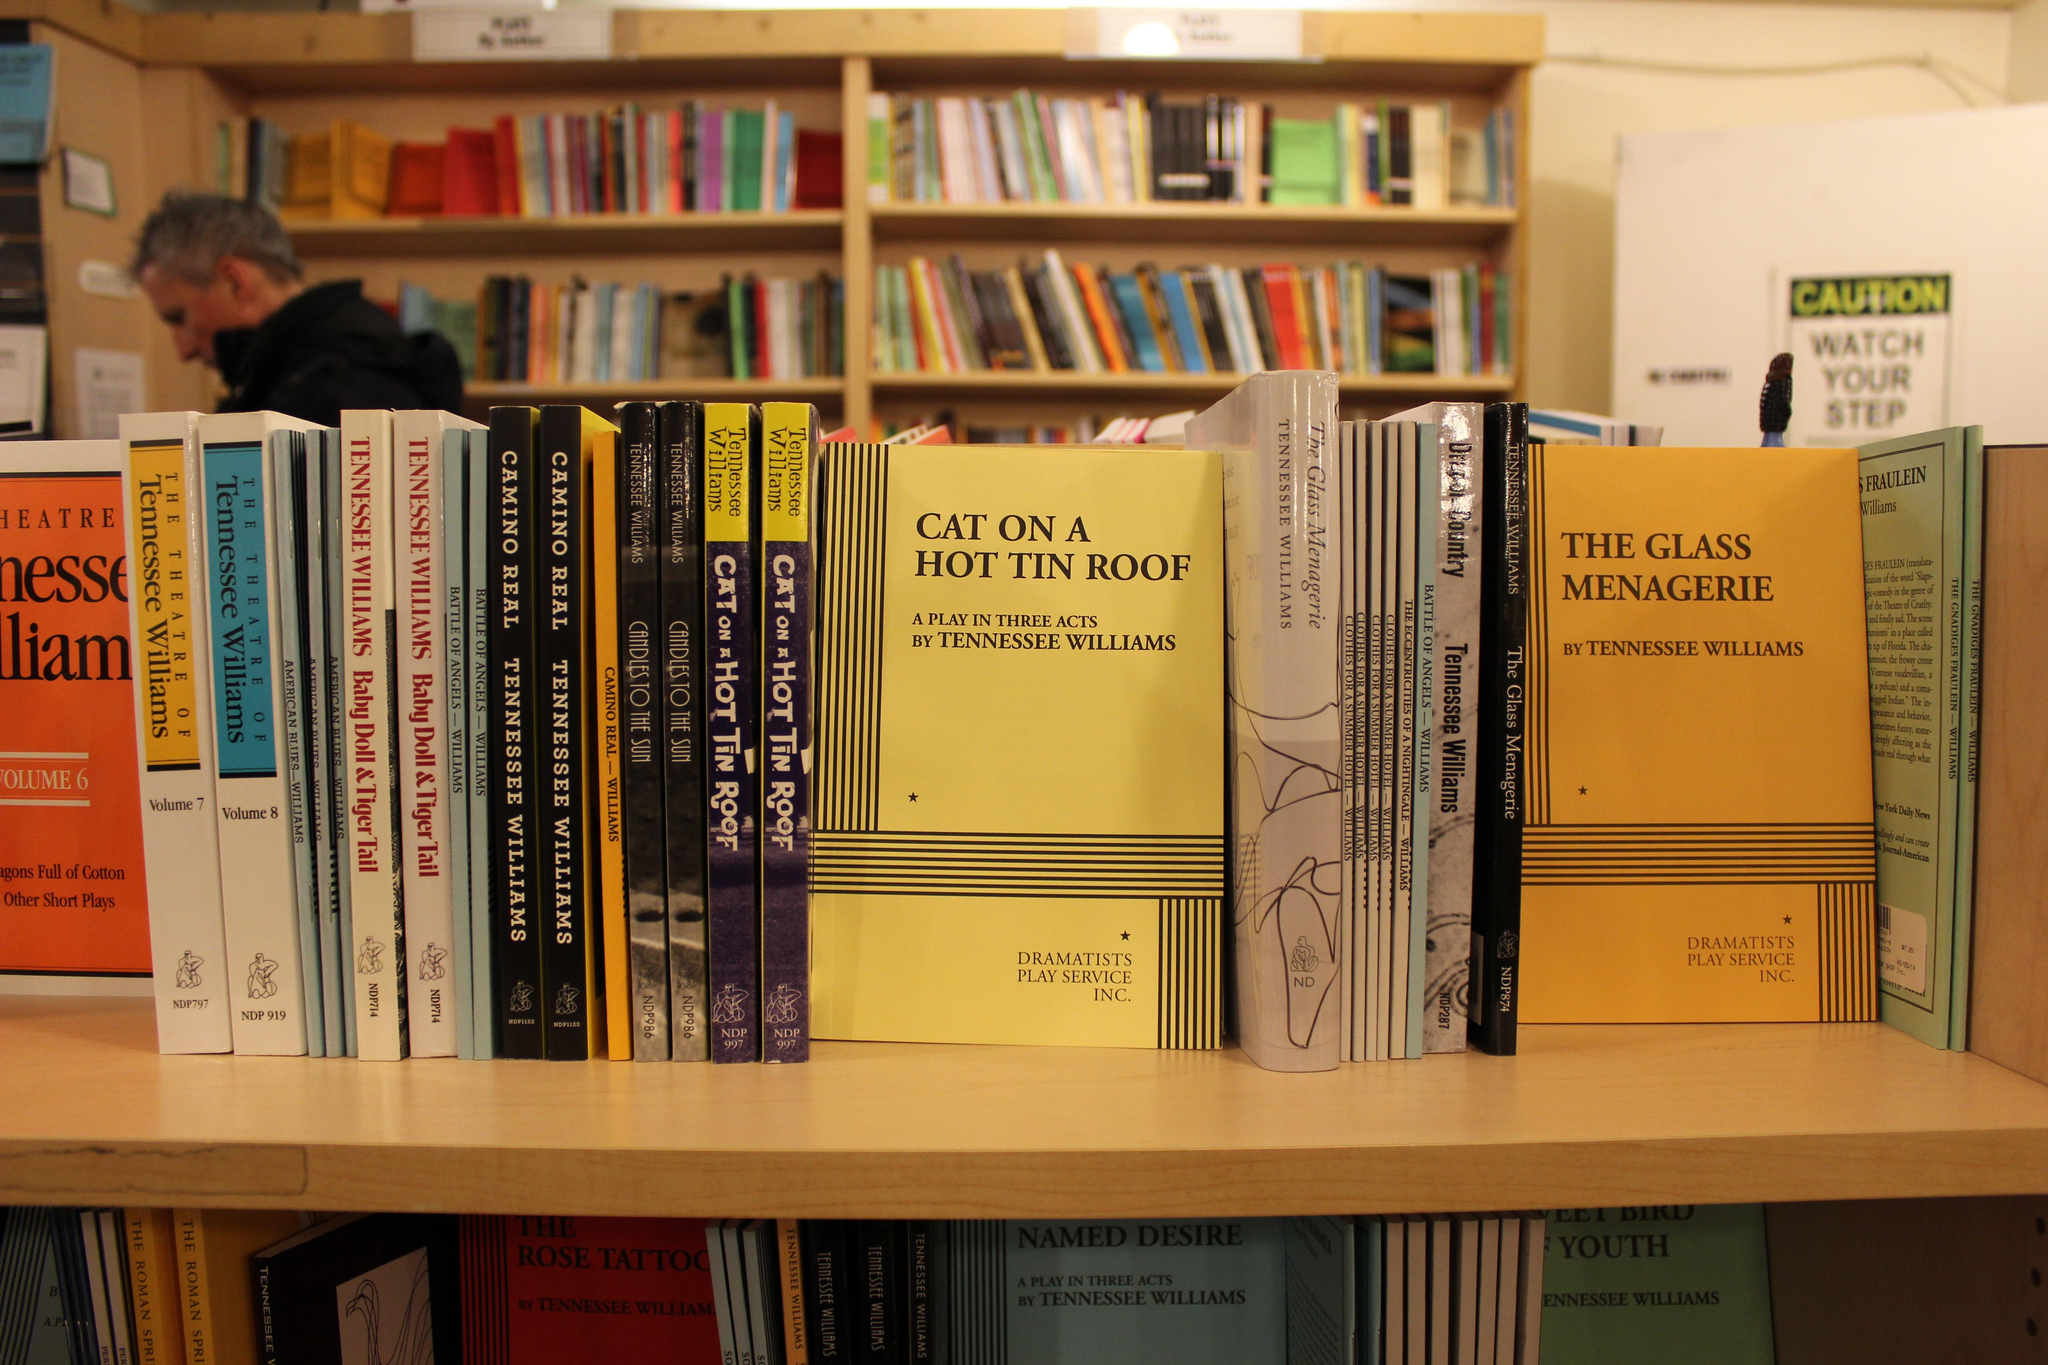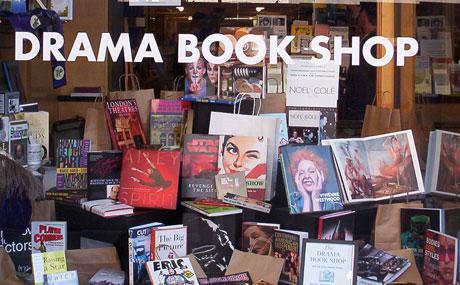The first image is the image on the left, the second image is the image on the right. Assess this claim about the two images: "there are two people in the image on the left.". Correct or not? Answer yes or no. No. 